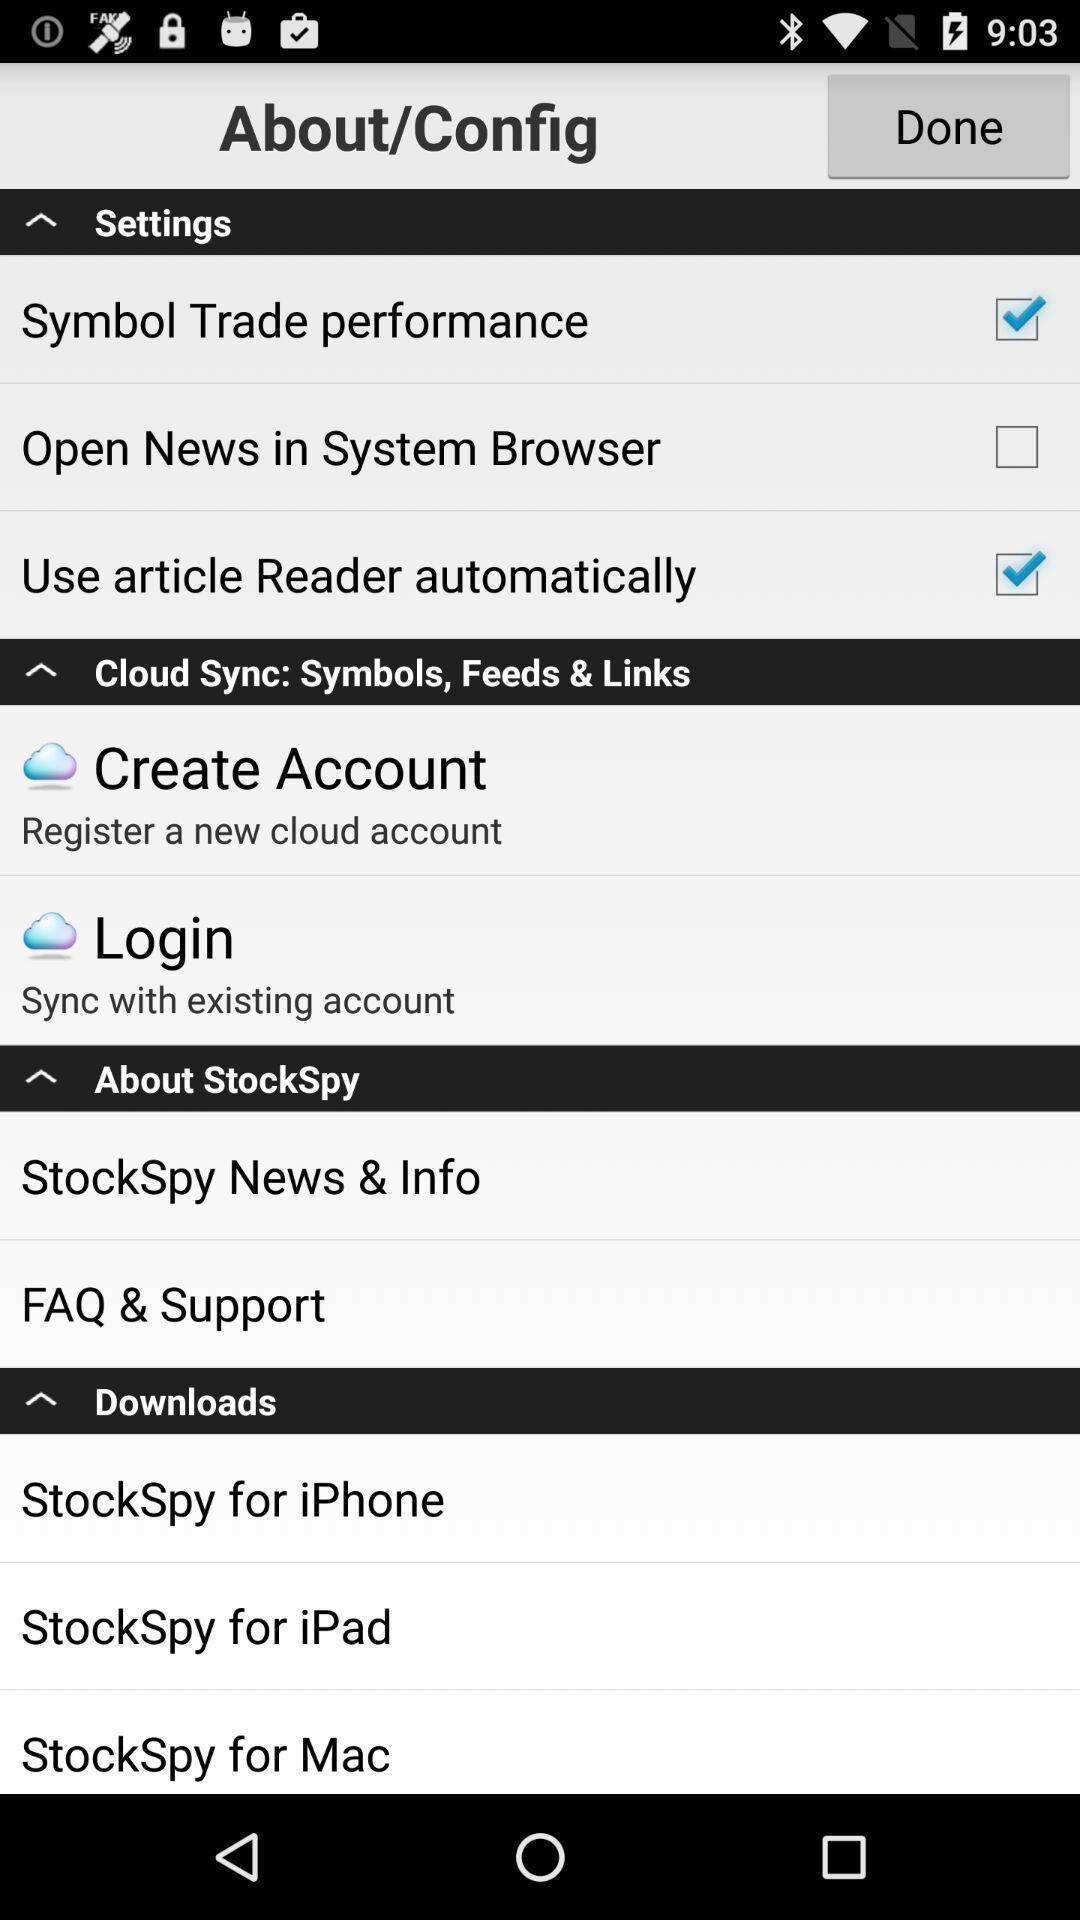What can you discern from this picture? Settings page and other different options displayed. 